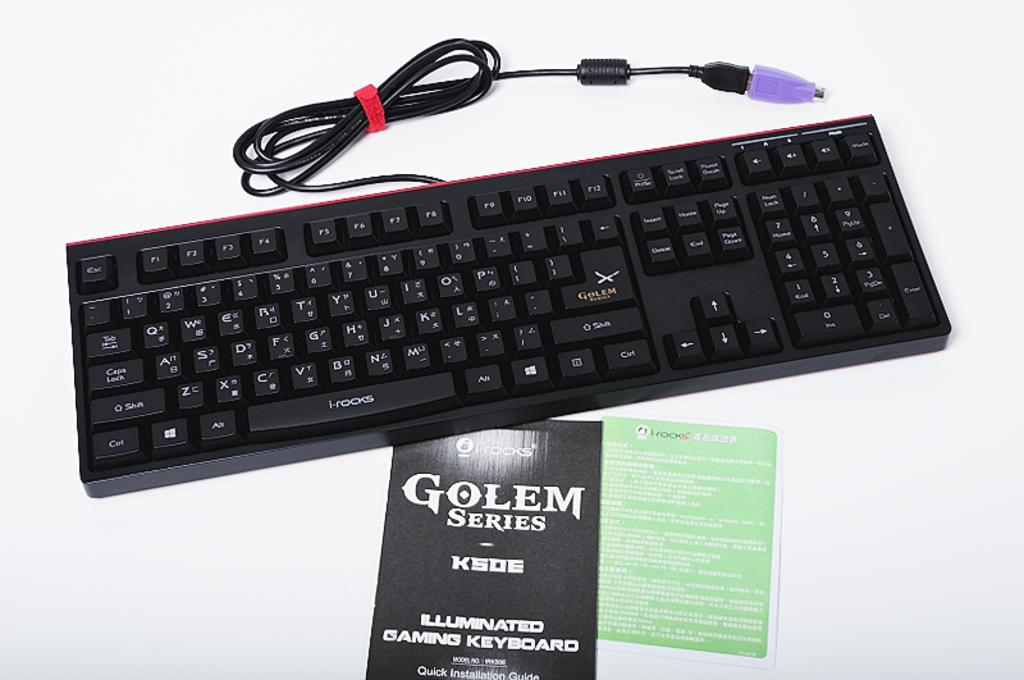<image>
Write a terse but informative summary of the picture. A leaflet sitting in front of a keyboard reads GOLEM SERIES. 